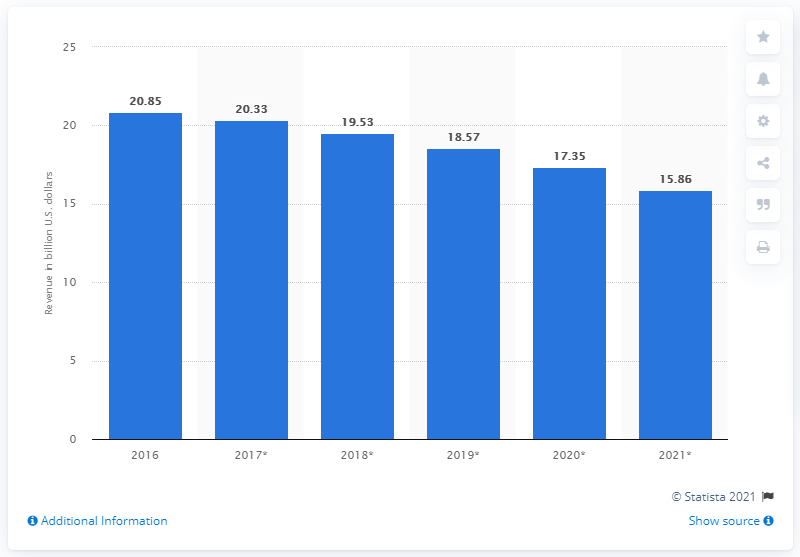Give some essential details in this illustration. The self-paced online learning market in the U.S. is projected to generate an estimated revenue of 15.86 by 2021. In 2016, the self-paced online learning market in the U.S. generated a revenue of approximately 20.85 billion U.S. dollars. 